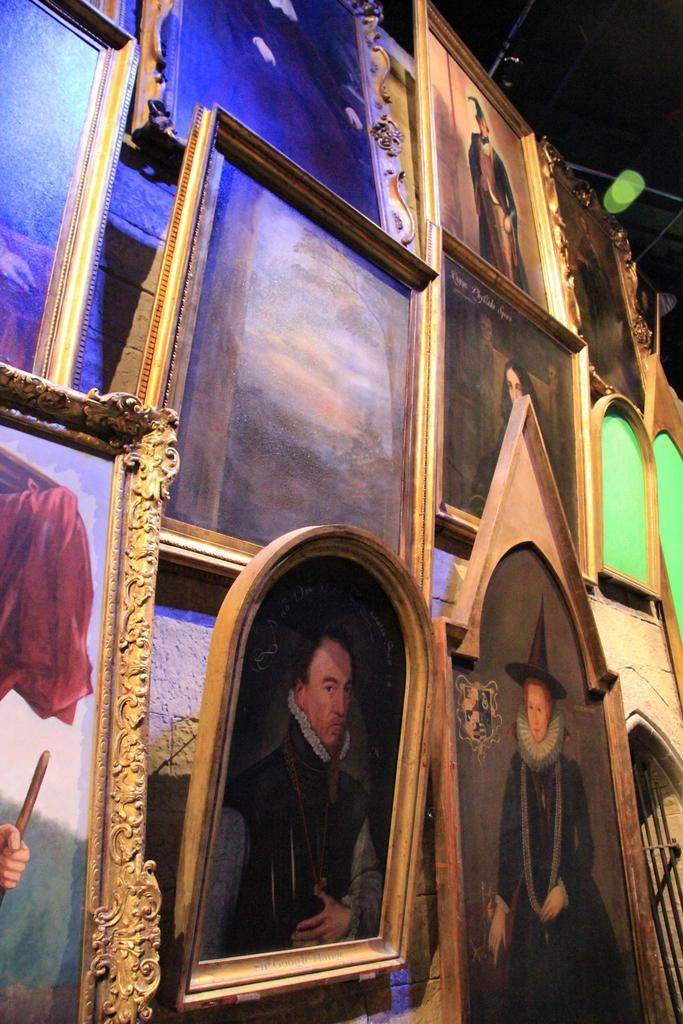What is the main subject of the image? The main subject of the image is many frames. Where are the frames located in the image? The frames are hung on the wall. What type of beast can be seen roaming through the frames in the image? There is no beast present in the image; it only features frames hung on the wall. What kind of trains are visible passing through the frames in the image? There are no trains visible in the image; it only features frames hung on the wall. 